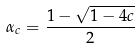Convert formula to latex. <formula><loc_0><loc_0><loc_500><loc_500>\alpha _ { c } = \frac { 1 - \sqrt { 1 - 4 c } } { 2 }</formula> 